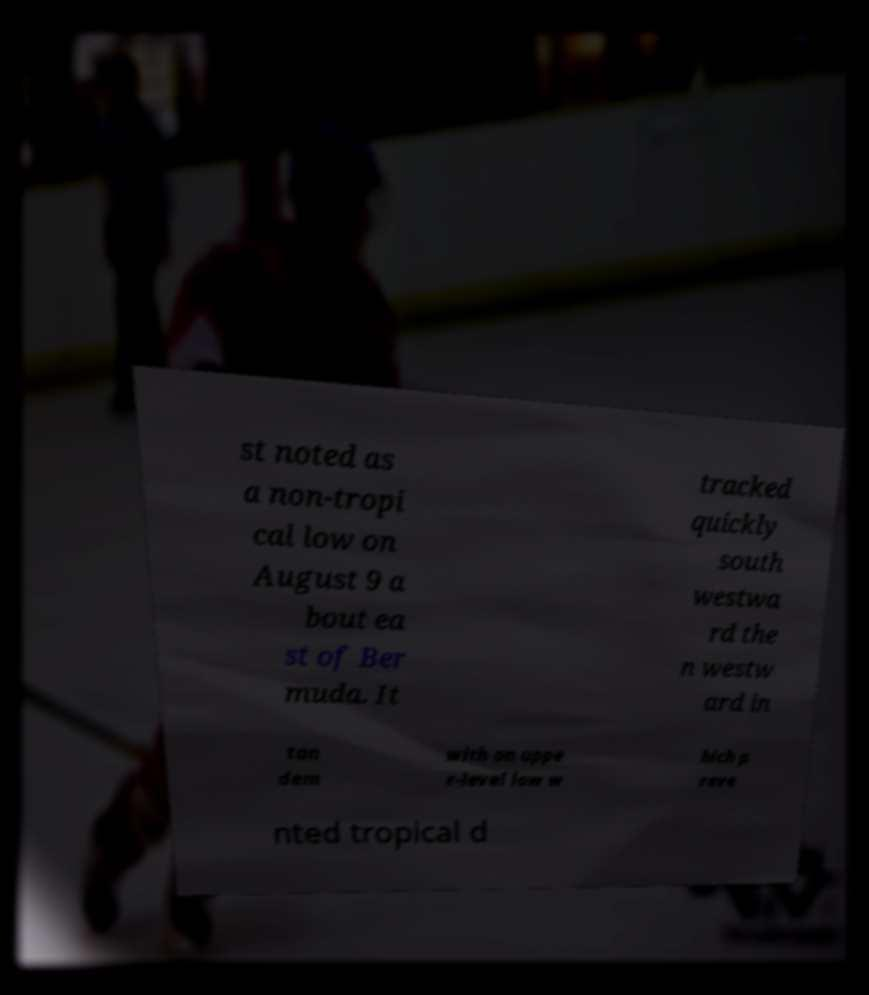I need the written content from this picture converted into text. Can you do that? st noted as a non-tropi cal low on August 9 a bout ea st of Ber muda. It tracked quickly south westwa rd the n westw ard in tan dem with an uppe r-level low w hich p reve nted tropical d 